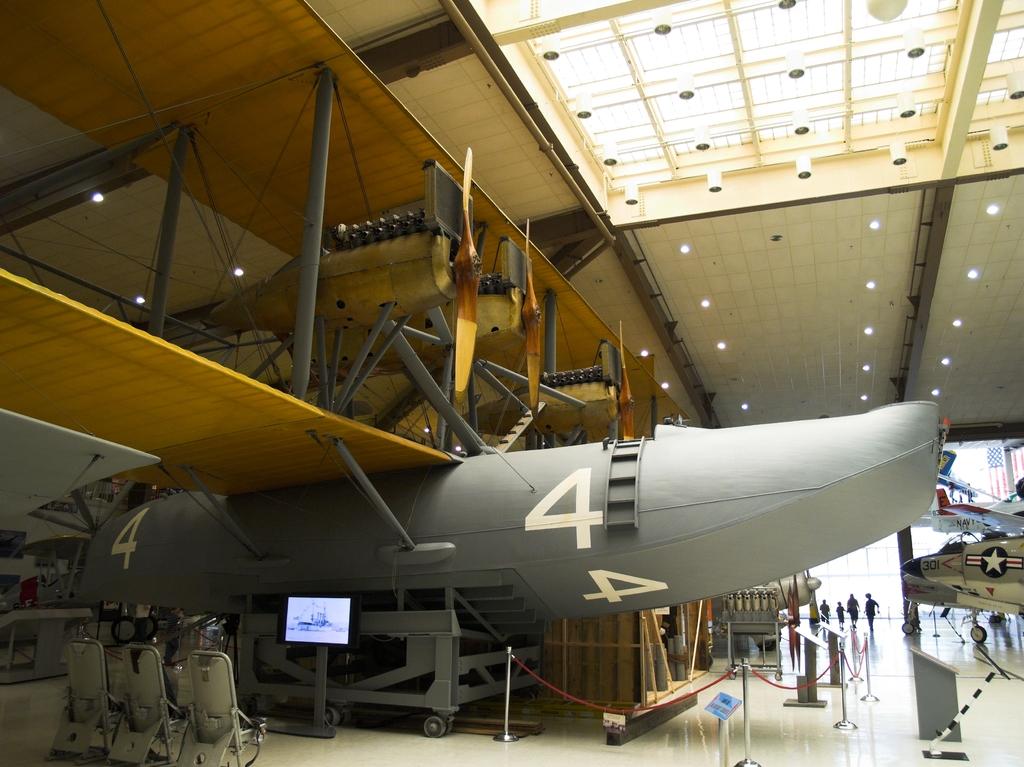What is the number on the airplane?
Your answer should be compact. 4. 